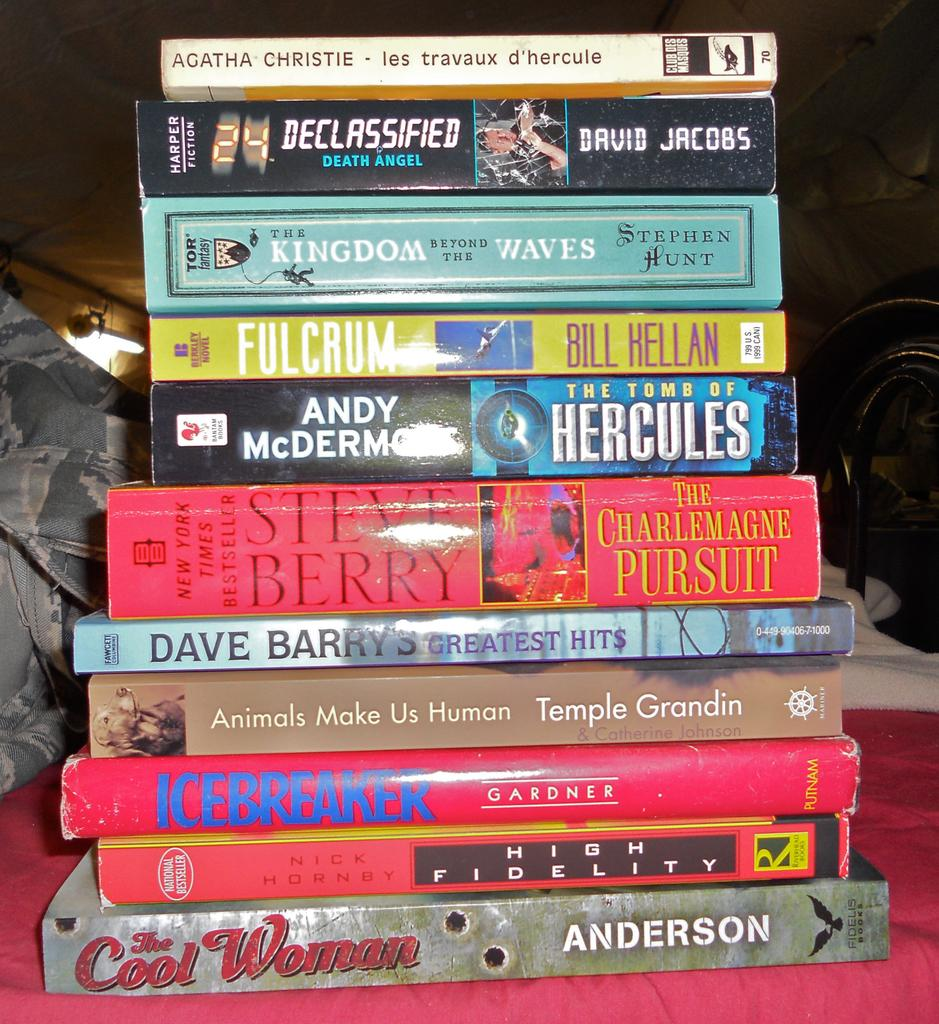Provide a one-sentence caption for the provided image. A stack of books including Dave Barry's Greatest Hits. 